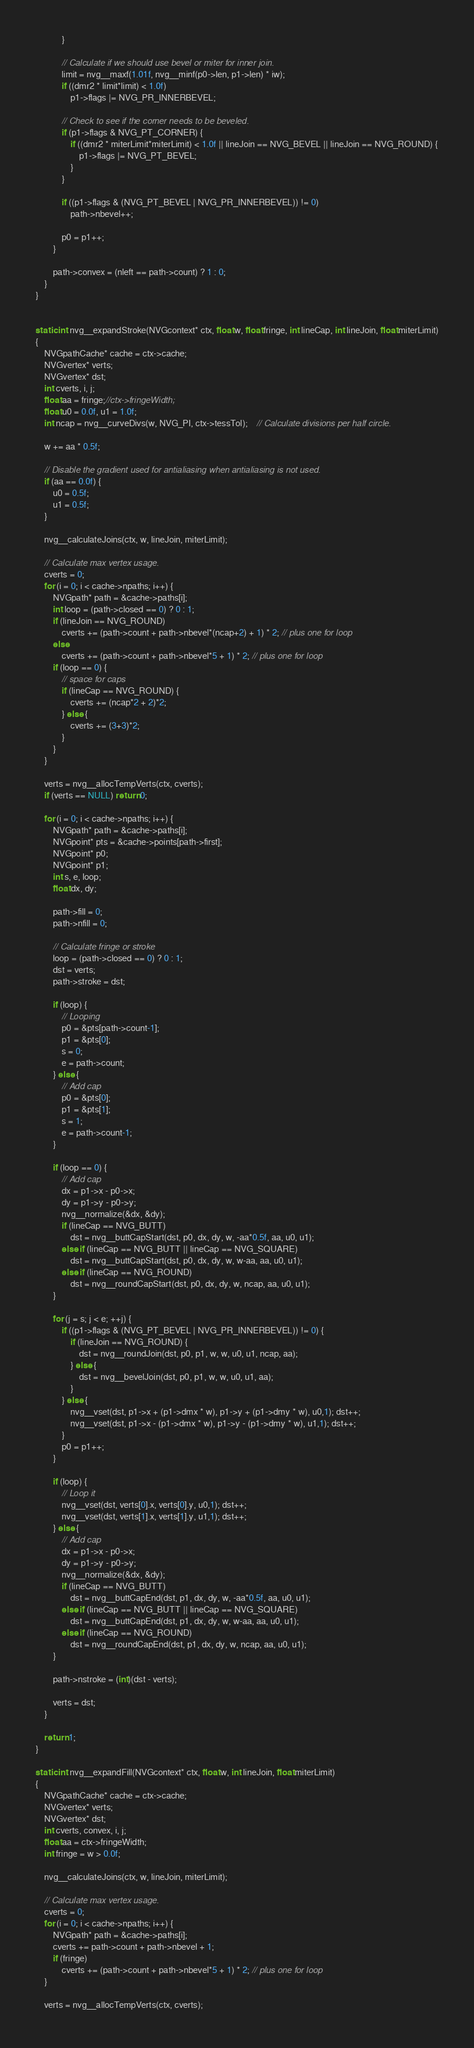Convert code to text. <code><loc_0><loc_0><loc_500><loc_500><_C_>			}

			// Calculate if we should use bevel or miter for inner join.
			limit = nvg__maxf(1.01f, nvg__minf(p0->len, p1->len) * iw);
			if ((dmr2 * limit*limit) < 1.0f)
				p1->flags |= NVG_PR_INNERBEVEL;

			// Check to see if the corner needs to be beveled.
			if (p1->flags & NVG_PT_CORNER) {
				if ((dmr2 * miterLimit*miterLimit) < 1.0f || lineJoin == NVG_BEVEL || lineJoin == NVG_ROUND) {
					p1->flags |= NVG_PT_BEVEL;
				}
			}

			if ((p1->flags & (NVG_PT_BEVEL | NVG_PR_INNERBEVEL)) != 0)
				path->nbevel++;

			p0 = p1++;
		}

		path->convex = (nleft == path->count) ? 1 : 0;
	}
}


static int nvg__expandStroke(NVGcontext* ctx, float w, float fringe, int lineCap, int lineJoin, float miterLimit)
{
	NVGpathCache* cache = ctx->cache;
	NVGvertex* verts;
	NVGvertex* dst;
	int cverts, i, j;
	float aa = fringe;//ctx->fringeWidth;
	float u0 = 0.0f, u1 = 1.0f;
	int ncap = nvg__curveDivs(w, NVG_PI, ctx->tessTol);	// Calculate divisions per half circle.

	w += aa * 0.5f;

	// Disable the gradient used for antialiasing when antialiasing is not used.
	if (aa == 0.0f) {
		u0 = 0.5f;
		u1 = 0.5f;
	}

	nvg__calculateJoins(ctx, w, lineJoin, miterLimit);

	// Calculate max vertex usage.
	cverts = 0;
	for (i = 0; i < cache->npaths; i++) {
		NVGpath* path = &cache->paths[i];
		int loop = (path->closed == 0) ? 0 : 1;
		if (lineJoin == NVG_ROUND)
			cverts += (path->count + path->nbevel*(ncap+2) + 1) * 2; // plus one for loop
		else
			cverts += (path->count + path->nbevel*5 + 1) * 2; // plus one for loop
		if (loop == 0) {
			// space for caps
			if (lineCap == NVG_ROUND) {
				cverts += (ncap*2 + 2)*2;
			} else {
				cverts += (3+3)*2;
			}
		}
	}

	verts = nvg__allocTempVerts(ctx, cverts);
	if (verts == NULL) return 0;

	for (i = 0; i < cache->npaths; i++) {
		NVGpath* path = &cache->paths[i];
		NVGpoint* pts = &cache->points[path->first];
		NVGpoint* p0;
		NVGpoint* p1;
		int s, e, loop;
		float dx, dy;

		path->fill = 0;
		path->nfill = 0;

		// Calculate fringe or stroke
		loop = (path->closed == 0) ? 0 : 1;
		dst = verts;
		path->stroke = dst;

		if (loop) {
			// Looping
			p0 = &pts[path->count-1];
			p1 = &pts[0];
			s = 0;
			e = path->count;
		} else {
			// Add cap
			p0 = &pts[0];
			p1 = &pts[1];
			s = 1;
			e = path->count-1;
		}

		if (loop == 0) {
			// Add cap
			dx = p1->x - p0->x;
			dy = p1->y - p0->y;
			nvg__normalize(&dx, &dy);
			if (lineCap == NVG_BUTT)
				dst = nvg__buttCapStart(dst, p0, dx, dy, w, -aa*0.5f, aa, u0, u1);
			else if (lineCap == NVG_BUTT || lineCap == NVG_SQUARE)
				dst = nvg__buttCapStart(dst, p0, dx, dy, w, w-aa, aa, u0, u1);
			else if (lineCap == NVG_ROUND)
				dst = nvg__roundCapStart(dst, p0, dx, dy, w, ncap, aa, u0, u1);
		}

		for (j = s; j < e; ++j) {
			if ((p1->flags & (NVG_PT_BEVEL | NVG_PR_INNERBEVEL)) != 0) {
				if (lineJoin == NVG_ROUND) {
					dst = nvg__roundJoin(dst, p0, p1, w, w, u0, u1, ncap, aa);
				} else {
					dst = nvg__bevelJoin(dst, p0, p1, w, w, u0, u1, aa);
				}
			} else {
				nvg__vset(dst, p1->x + (p1->dmx * w), p1->y + (p1->dmy * w), u0,1); dst++;
				nvg__vset(dst, p1->x - (p1->dmx * w), p1->y - (p1->dmy * w), u1,1); dst++;
			}
			p0 = p1++;
		}

		if (loop) {
			// Loop it
			nvg__vset(dst, verts[0].x, verts[0].y, u0,1); dst++;
			nvg__vset(dst, verts[1].x, verts[1].y, u1,1); dst++;
		} else {
			// Add cap
			dx = p1->x - p0->x;
			dy = p1->y - p0->y;
			nvg__normalize(&dx, &dy);
			if (lineCap == NVG_BUTT)
				dst = nvg__buttCapEnd(dst, p1, dx, dy, w, -aa*0.5f, aa, u0, u1);
			else if (lineCap == NVG_BUTT || lineCap == NVG_SQUARE)
				dst = nvg__buttCapEnd(dst, p1, dx, dy, w, w-aa, aa, u0, u1);
			else if (lineCap == NVG_ROUND)
				dst = nvg__roundCapEnd(dst, p1, dx, dy, w, ncap, aa, u0, u1);
		}

		path->nstroke = (int)(dst - verts);

		verts = dst;
	}

	return 1;
}

static int nvg__expandFill(NVGcontext* ctx, float w, int lineJoin, float miterLimit)
{
	NVGpathCache* cache = ctx->cache;
	NVGvertex* verts;
	NVGvertex* dst;
	int cverts, convex, i, j;
	float aa = ctx->fringeWidth;
	int fringe = w > 0.0f;

	nvg__calculateJoins(ctx, w, lineJoin, miterLimit);

	// Calculate max vertex usage.
	cverts = 0;
	for (i = 0; i < cache->npaths; i++) {
		NVGpath* path = &cache->paths[i];
		cverts += path->count + path->nbevel + 1;
		if (fringe)
			cverts += (path->count + path->nbevel*5 + 1) * 2; // plus one for loop
	}

	verts = nvg__allocTempVerts(ctx, cverts);</code> 